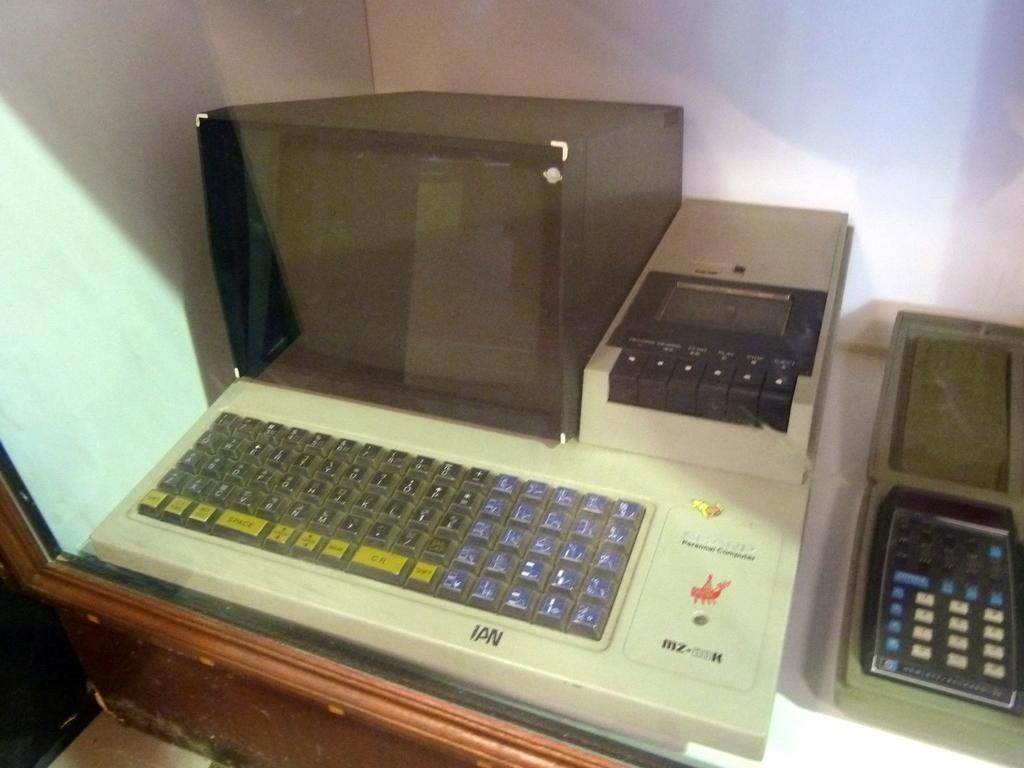<image>
Relay a brief, clear account of the picture shown. Inside of a display case, on the lower right is a old HP brand calculator. 